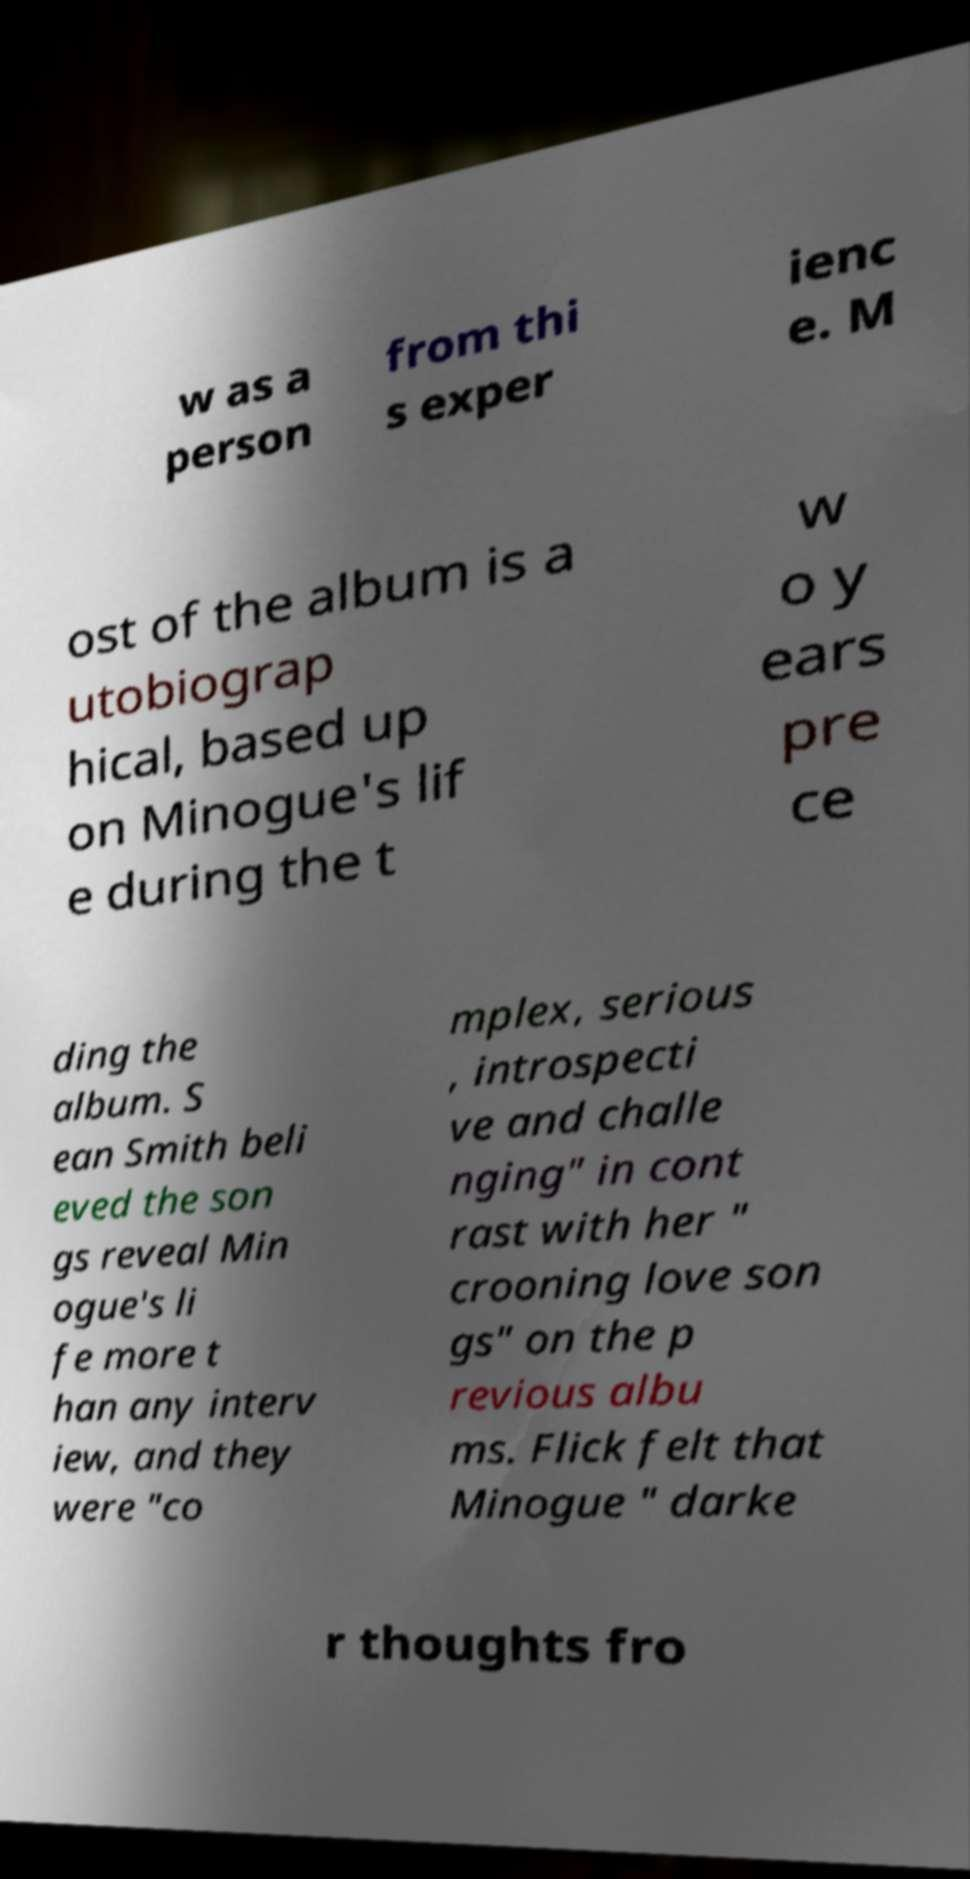I need the written content from this picture converted into text. Can you do that? w as a person from thi s exper ienc e. M ost of the album is a utobiograp hical, based up on Minogue's lif e during the t w o y ears pre ce ding the album. S ean Smith beli eved the son gs reveal Min ogue's li fe more t han any interv iew, and they were "co mplex, serious , introspecti ve and challe nging" in cont rast with her " crooning love son gs" on the p revious albu ms. Flick felt that Minogue " darke r thoughts fro 